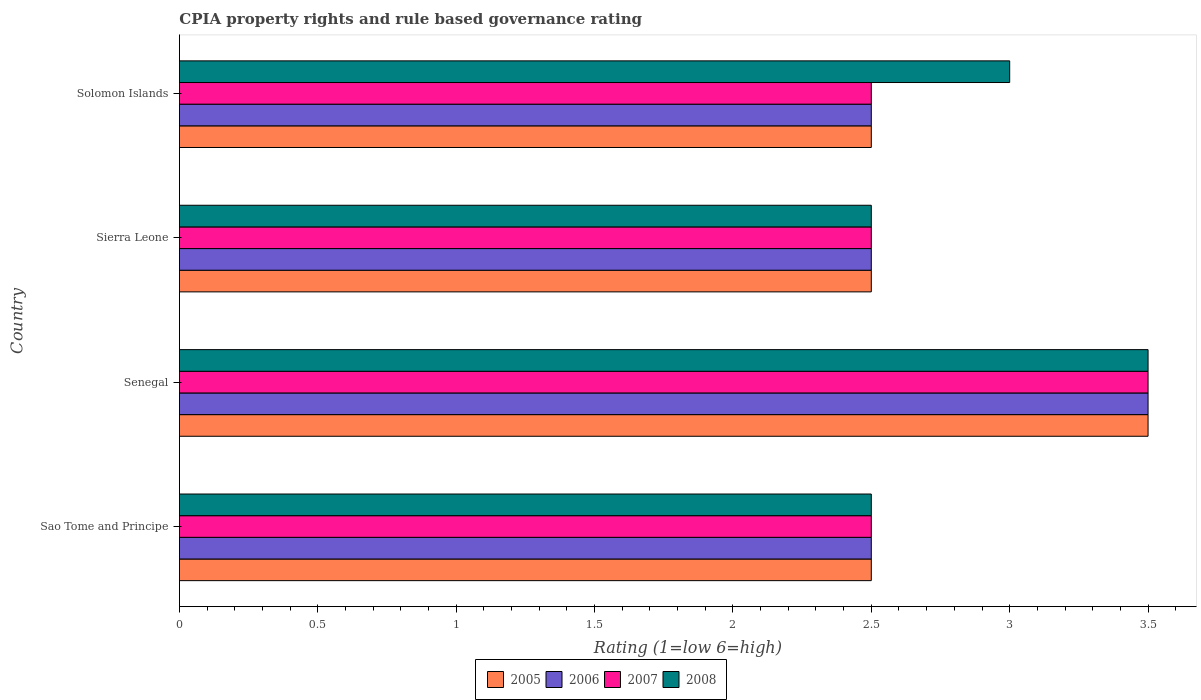How many different coloured bars are there?
Ensure brevity in your answer.  4. How many groups of bars are there?
Provide a short and direct response. 4. Are the number of bars per tick equal to the number of legend labels?
Your answer should be compact. Yes. How many bars are there on the 3rd tick from the top?
Offer a very short reply. 4. What is the label of the 1st group of bars from the top?
Provide a succinct answer. Solomon Islands. In which country was the CPIA rating in 2007 maximum?
Your response must be concise. Senegal. In which country was the CPIA rating in 2005 minimum?
Keep it short and to the point. Sao Tome and Principe. What is the total CPIA rating in 2006 in the graph?
Keep it short and to the point. 11. What is the difference between the CPIA rating in 2008 in Senegal and that in Sierra Leone?
Your answer should be compact. 1. What is the average CPIA rating in 2007 per country?
Offer a terse response. 2.75. What is the difference between the CPIA rating in 2008 and CPIA rating in 2007 in Senegal?
Provide a short and direct response. 0. In how many countries, is the CPIA rating in 2008 greater than 2.3 ?
Provide a short and direct response. 4. What is the ratio of the CPIA rating in 2005 in Sao Tome and Principe to that in Sierra Leone?
Your response must be concise. 1. Is the difference between the CPIA rating in 2008 in Senegal and Sierra Leone greater than the difference between the CPIA rating in 2007 in Senegal and Sierra Leone?
Make the answer very short. No. What is the difference between the highest and the second highest CPIA rating in 2005?
Provide a short and direct response. 1. In how many countries, is the CPIA rating in 2007 greater than the average CPIA rating in 2007 taken over all countries?
Make the answer very short. 1. What does the 4th bar from the top in Sao Tome and Principe represents?
Your answer should be very brief. 2005. Is it the case that in every country, the sum of the CPIA rating in 2008 and CPIA rating in 2007 is greater than the CPIA rating in 2006?
Keep it short and to the point. Yes. How many bars are there?
Keep it short and to the point. 16. Are all the bars in the graph horizontal?
Make the answer very short. Yes. What is the difference between two consecutive major ticks on the X-axis?
Your response must be concise. 0.5. Are the values on the major ticks of X-axis written in scientific E-notation?
Make the answer very short. No. Does the graph contain any zero values?
Your answer should be compact. No. Where does the legend appear in the graph?
Ensure brevity in your answer.  Bottom center. How many legend labels are there?
Your response must be concise. 4. How are the legend labels stacked?
Your response must be concise. Horizontal. What is the title of the graph?
Provide a short and direct response. CPIA property rights and rule based governance rating. What is the Rating (1=low 6=high) of 2005 in Sao Tome and Principe?
Provide a short and direct response. 2.5. What is the Rating (1=low 6=high) of 2007 in Sao Tome and Principe?
Offer a terse response. 2.5. What is the Rating (1=low 6=high) of 2008 in Sao Tome and Principe?
Give a very brief answer. 2.5. What is the Rating (1=low 6=high) in 2008 in Senegal?
Ensure brevity in your answer.  3.5. What is the Rating (1=low 6=high) of 2005 in Sierra Leone?
Offer a very short reply. 2.5. What is the Rating (1=low 6=high) in 2006 in Sierra Leone?
Your answer should be compact. 2.5. What is the Rating (1=low 6=high) of 2007 in Sierra Leone?
Offer a very short reply. 2.5. What is the Rating (1=low 6=high) in 2008 in Sierra Leone?
Your answer should be very brief. 2.5. What is the Rating (1=low 6=high) in 2005 in Solomon Islands?
Your response must be concise. 2.5. What is the Rating (1=low 6=high) of 2007 in Solomon Islands?
Provide a short and direct response. 2.5. What is the Rating (1=low 6=high) in 2008 in Solomon Islands?
Offer a very short reply. 3. Across all countries, what is the maximum Rating (1=low 6=high) of 2008?
Give a very brief answer. 3.5. Across all countries, what is the minimum Rating (1=low 6=high) in 2005?
Your response must be concise. 2.5. Across all countries, what is the minimum Rating (1=low 6=high) of 2008?
Your answer should be compact. 2.5. What is the total Rating (1=low 6=high) of 2005 in the graph?
Provide a short and direct response. 11. What is the total Rating (1=low 6=high) of 2006 in the graph?
Offer a terse response. 11. What is the difference between the Rating (1=low 6=high) in 2005 in Sao Tome and Principe and that in Senegal?
Give a very brief answer. -1. What is the difference between the Rating (1=low 6=high) of 2008 in Sao Tome and Principe and that in Senegal?
Your answer should be very brief. -1. What is the difference between the Rating (1=low 6=high) of 2005 in Sao Tome and Principe and that in Sierra Leone?
Provide a short and direct response. 0. What is the difference between the Rating (1=low 6=high) of 2007 in Sao Tome and Principe and that in Sierra Leone?
Give a very brief answer. 0. What is the difference between the Rating (1=low 6=high) of 2008 in Sao Tome and Principe and that in Sierra Leone?
Give a very brief answer. 0. What is the difference between the Rating (1=low 6=high) of 2006 in Sao Tome and Principe and that in Solomon Islands?
Keep it short and to the point. 0. What is the difference between the Rating (1=low 6=high) in 2007 in Sao Tome and Principe and that in Solomon Islands?
Make the answer very short. 0. What is the difference between the Rating (1=low 6=high) of 2008 in Sao Tome and Principe and that in Solomon Islands?
Offer a terse response. -0.5. What is the difference between the Rating (1=low 6=high) of 2005 in Senegal and that in Sierra Leone?
Provide a succinct answer. 1. What is the difference between the Rating (1=low 6=high) in 2006 in Senegal and that in Sierra Leone?
Give a very brief answer. 1. What is the difference between the Rating (1=low 6=high) in 2008 in Senegal and that in Sierra Leone?
Offer a terse response. 1. What is the difference between the Rating (1=low 6=high) in 2005 in Senegal and that in Solomon Islands?
Make the answer very short. 1. What is the difference between the Rating (1=low 6=high) of 2006 in Senegal and that in Solomon Islands?
Your response must be concise. 1. What is the difference between the Rating (1=low 6=high) of 2007 in Senegal and that in Solomon Islands?
Offer a terse response. 1. What is the difference between the Rating (1=low 6=high) of 2008 in Senegal and that in Solomon Islands?
Ensure brevity in your answer.  0.5. What is the difference between the Rating (1=low 6=high) in 2006 in Sierra Leone and that in Solomon Islands?
Offer a very short reply. 0. What is the difference between the Rating (1=low 6=high) of 2007 in Sierra Leone and that in Solomon Islands?
Provide a short and direct response. 0. What is the difference between the Rating (1=low 6=high) of 2005 in Sao Tome and Principe and the Rating (1=low 6=high) of 2007 in Senegal?
Keep it short and to the point. -1. What is the difference between the Rating (1=low 6=high) in 2005 in Sao Tome and Principe and the Rating (1=low 6=high) in 2008 in Senegal?
Give a very brief answer. -1. What is the difference between the Rating (1=low 6=high) in 2006 in Sao Tome and Principe and the Rating (1=low 6=high) in 2007 in Senegal?
Provide a short and direct response. -1. What is the difference between the Rating (1=low 6=high) of 2006 in Sao Tome and Principe and the Rating (1=low 6=high) of 2008 in Senegal?
Offer a very short reply. -1. What is the difference between the Rating (1=low 6=high) of 2007 in Sao Tome and Principe and the Rating (1=low 6=high) of 2008 in Senegal?
Provide a short and direct response. -1. What is the difference between the Rating (1=low 6=high) of 2005 in Sao Tome and Principe and the Rating (1=low 6=high) of 2007 in Sierra Leone?
Your answer should be very brief. 0. What is the difference between the Rating (1=low 6=high) of 2005 in Sao Tome and Principe and the Rating (1=low 6=high) of 2008 in Sierra Leone?
Give a very brief answer. 0. What is the difference between the Rating (1=low 6=high) of 2006 in Sao Tome and Principe and the Rating (1=low 6=high) of 2007 in Sierra Leone?
Keep it short and to the point. 0. What is the difference between the Rating (1=low 6=high) in 2005 in Sao Tome and Principe and the Rating (1=low 6=high) in 2006 in Solomon Islands?
Give a very brief answer. 0. What is the difference between the Rating (1=low 6=high) of 2005 in Sao Tome and Principe and the Rating (1=low 6=high) of 2007 in Solomon Islands?
Your answer should be compact. 0. What is the difference between the Rating (1=low 6=high) of 2006 in Sao Tome and Principe and the Rating (1=low 6=high) of 2007 in Solomon Islands?
Your answer should be very brief. 0. What is the difference between the Rating (1=low 6=high) of 2006 in Senegal and the Rating (1=low 6=high) of 2007 in Sierra Leone?
Ensure brevity in your answer.  1. What is the difference between the Rating (1=low 6=high) of 2005 in Senegal and the Rating (1=low 6=high) of 2007 in Solomon Islands?
Ensure brevity in your answer.  1. What is the difference between the Rating (1=low 6=high) in 2005 in Sierra Leone and the Rating (1=low 6=high) in 2006 in Solomon Islands?
Make the answer very short. 0. What is the difference between the Rating (1=low 6=high) in 2005 in Sierra Leone and the Rating (1=low 6=high) in 2008 in Solomon Islands?
Provide a short and direct response. -0.5. What is the difference between the Rating (1=low 6=high) in 2006 in Sierra Leone and the Rating (1=low 6=high) in 2008 in Solomon Islands?
Give a very brief answer. -0.5. What is the average Rating (1=low 6=high) in 2005 per country?
Give a very brief answer. 2.75. What is the average Rating (1=low 6=high) of 2006 per country?
Offer a very short reply. 2.75. What is the average Rating (1=low 6=high) of 2007 per country?
Provide a short and direct response. 2.75. What is the average Rating (1=low 6=high) of 2008 per country?
Keep it short and to the point. 2.88. What is the difference between the Rating (1=low 6=high) in 2006 and Rating (1=low 6=high) in 2007 in Sao Tome and Principe?
Your answer should be very brief. 0. What is the difference between the Rating (1=low 6=high) of 2006 and Rating (1=low 6=high) of 2008 in Sao Tome and Principe?
Offer a terse response. 0. What is the difference between the Rating (1=low 6=high) of 2007 and Rating (1=low 6=high) of 2008 in Sao Tome and Principe?
Offer a very short reply. 0. What is the difference between the Rating (1=low 6=high) of 2006 and Rating (1=low 6=high) of 2007 in Senegal?
Your answer should be very brief. 0. What is the difference between the Rating (1=low 6=high) of 2006 and Rating (1=low 6=high) of 2008 in Senegal?
Keep it short and to the point. 0. What is the difference between the Rating (1=low 6=high) in 2007 and Rating (1=low 6=high) in 2008 in Senegal?
Your answer should be compact. 0. What is the difference between the Rating (1=low 6=high) in 2005 and Rating (1=low 6=high) in 2006 in Sierra Leone?
Give a very brief answer. 0. What is the difference between the Rating (1=low 6=high) of 2006 and Rating (1=low 6=high) of 2008 in Sierra Leone?
Your answer should be compact. 0. What is the difference between the Rating (1=low 6=high) in 2005 and Rating (1=low 6=high) in 2006 in Solomon Islands?
Provide a succinct answer. 0. What is the difference between the Rating (1=low 6=high) in 2006 and Rating (1=low 6=high) in 2007 in Solomon Islands?
Your answer should be very brief. 0. What is the difference between the Rating (1=low 6=high) in 2006 and Rating (1=low 6=high) in 2008 in Solomon Islands?
Give a very brief answer. -0.5. What is the ratio of the Rating (1=low 6=high) of 2005 in Sao Tome and Principe to that in Senegal?
Ensure brevity in your answer.  0.71. What is the ratio of the Rating (1=low 6=high) in 2007 in Sao Tome and Principe to that in Senegal?
Provide a succinct answer. 0.71. What is the ratio of the Rating (1=low 6=high) of 2008 in Sao Tome and Principe to that in Senegal?
Offer a very short reply. 0.71. What is the ratio of the Rating (1=low 6=high) of 2005 in Sao Tome and Principe to that in Sierra Leone?
Ensure brevity in your answer.  1. What is the ratio of the Rating (1=low 6=high) of 2006 in Sao Tome and Principe to that in Sierra Leone?
Provide a succinct answer. 1. What is the ratio of the Rating (1=low 6=high) of 2007 in Sao Tome and Principe to that in Sierra Leone?
Your answer should be compact. 1. What is the ratio of the Rating (1=low 6=high) of 2008 in Sao Tome and Principe to that in Sierra Leone?
Provide a short and direct response. 1. What is the ratio of the Rating (1=low 6=high) in 2006 in Sao Tome and Principe to that in Solomon Islands?
Ensure brevity in your answer.  1. What is the ratio of the Rating (1=low 6=high) of 2007 in Senegal to that in Solomon Islands?
Make the answer very short. 1.4. What is the ratio of the Rating (1=low 6=high) of 2008 in Senegal to that in Solomon Islands?
Keep it short and to the point. 1.17. What is the ratio of the Rating (1=low 6=high) of 2007 in Sierra Leone to that in Solomon Islands?
Provide a short and direct response. 1. What is the difference between the highest and the second highest Rating (1=low 6=high) in 2006?
Provide a succinct answer. 1. What is the difference between the highest and the lowest Rating (1=low 6=high) in 2007?
Ensure brevity in your answer.  1. What is the difference between the highest and the lowest Rating (1=low 6=high) of 2008?
Give a very brief answer. 1. 